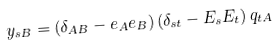Convert formula to latex. <formula><loc_0><loc_0><loc_500><loc_500>y _ { s B } = ( \delta _ { A B } - e _ { A } e _ { B } ) \, ( \delta _ { s t } - E _ { s } E _ { t } ) \, q _ { t A }</formula> 